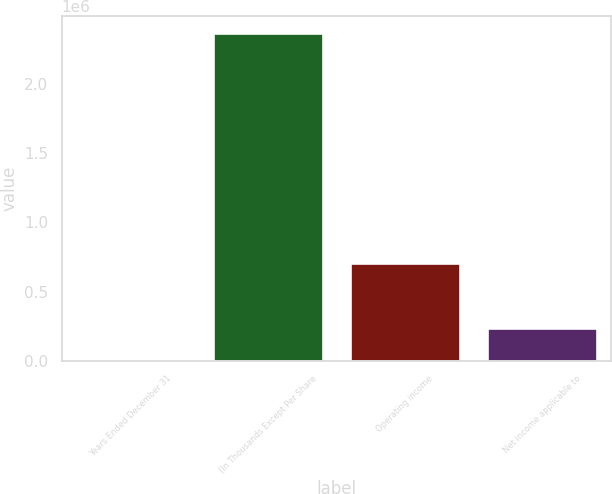Convert chart. <chart><loc_0><loc_0><loc_500><loc_500><bar_chart><fcel>Years Ended December 31<fcel>(In Thousands Except Per Share<fcel>Operating income<fcel>Net income applicable to<nl><fcel>2004<fcel>2.37187e+06<fcel>703576<fcel>238990<nl></chart> 